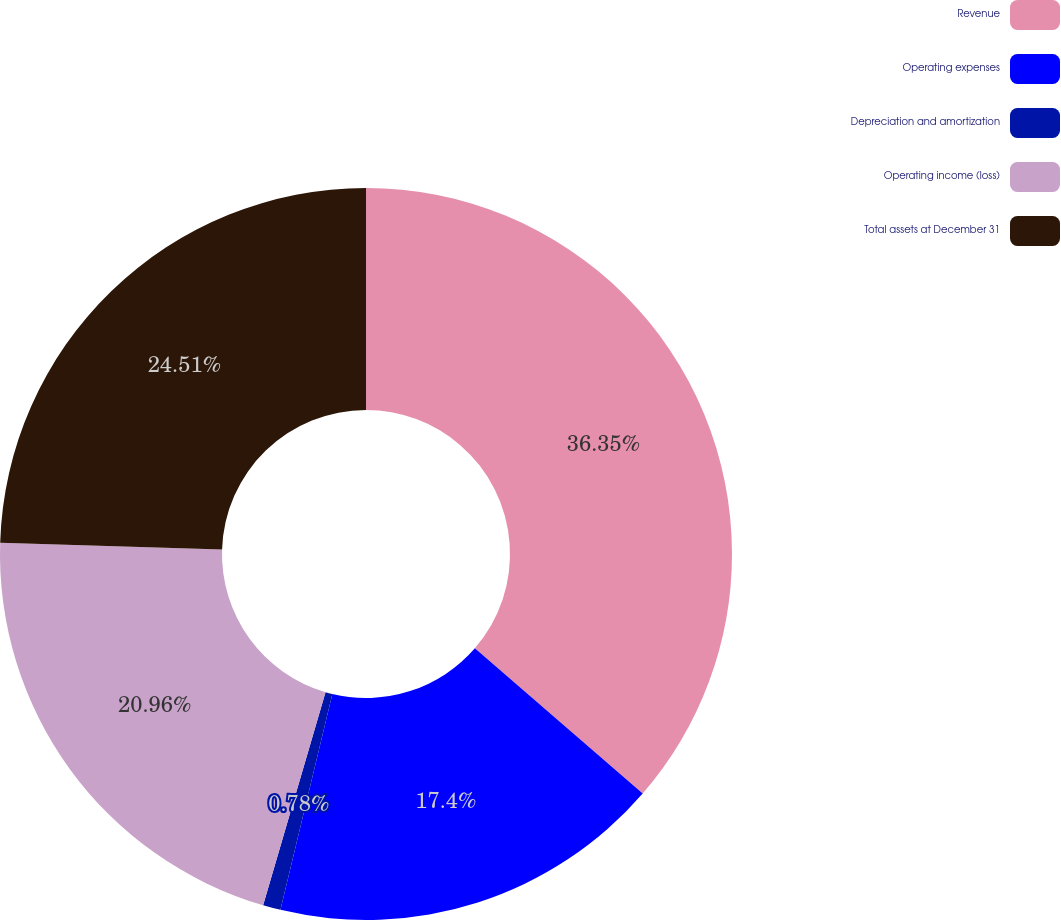Convert chart to OTSL. <chart><loc_0><loc_0><loc_500><loc_500><pie_chart><fcel>Revenue<fcel>Operating expenses<fcel>Depreciation and amortization<fcel>Operating income (loss)<fcel>Total assets at December 31<nl><fcel>36.36%<fcel>17.4%<fcel>0.78%<fcel>20.96%<fcel>24.51%<nl></chart> 